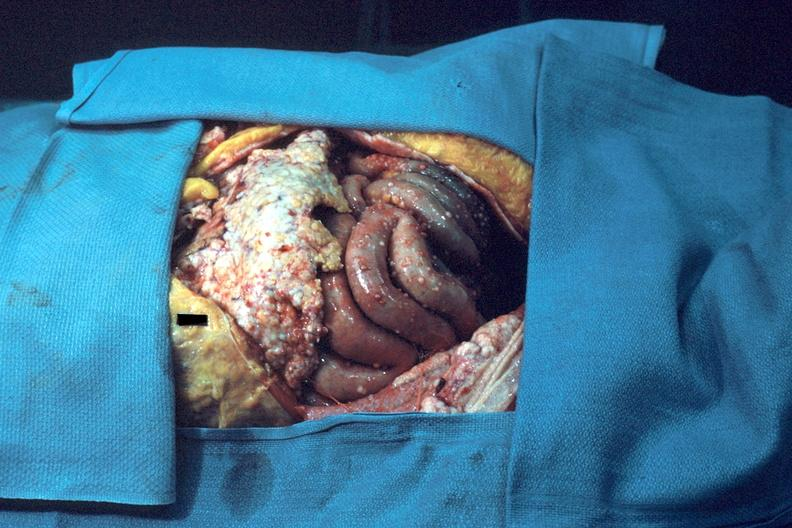s omentum present?
Answer the question using a single word or phrase. No 